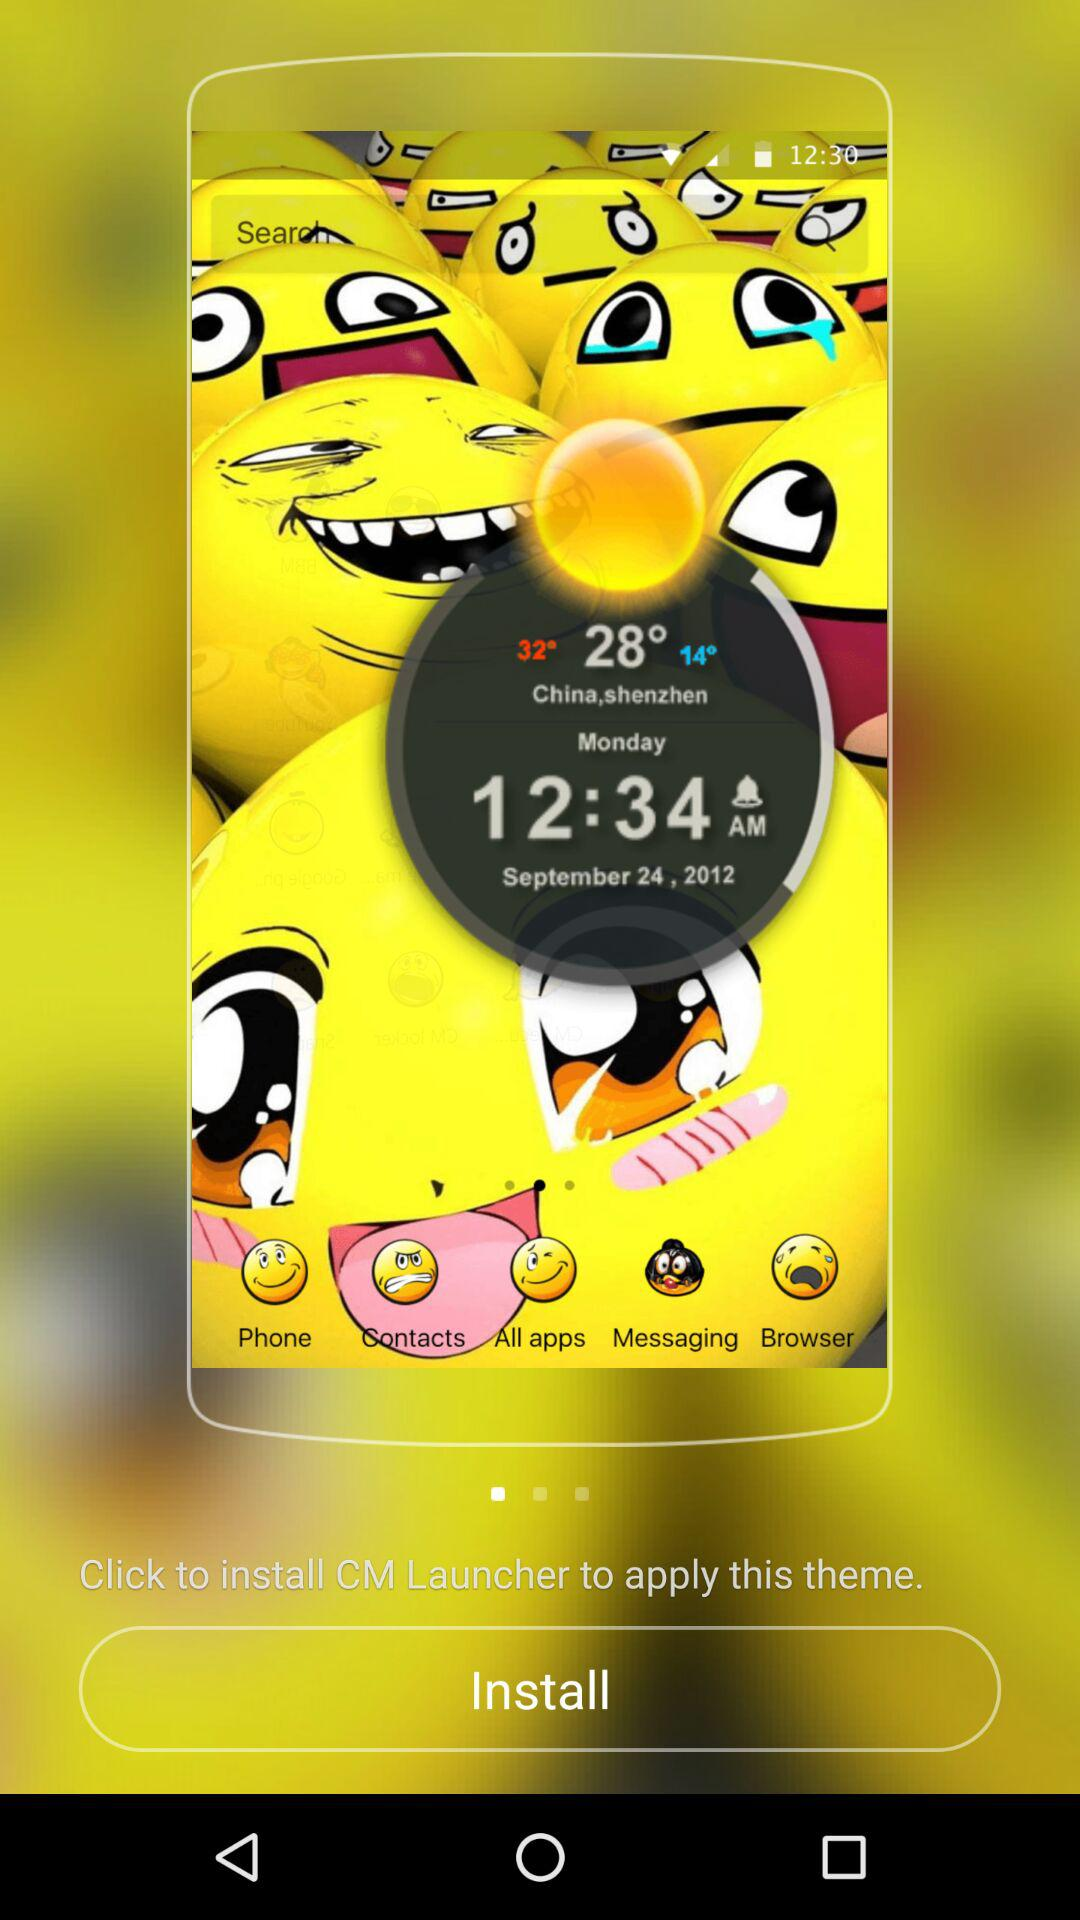What is the time? The time is 12:34 AM. 